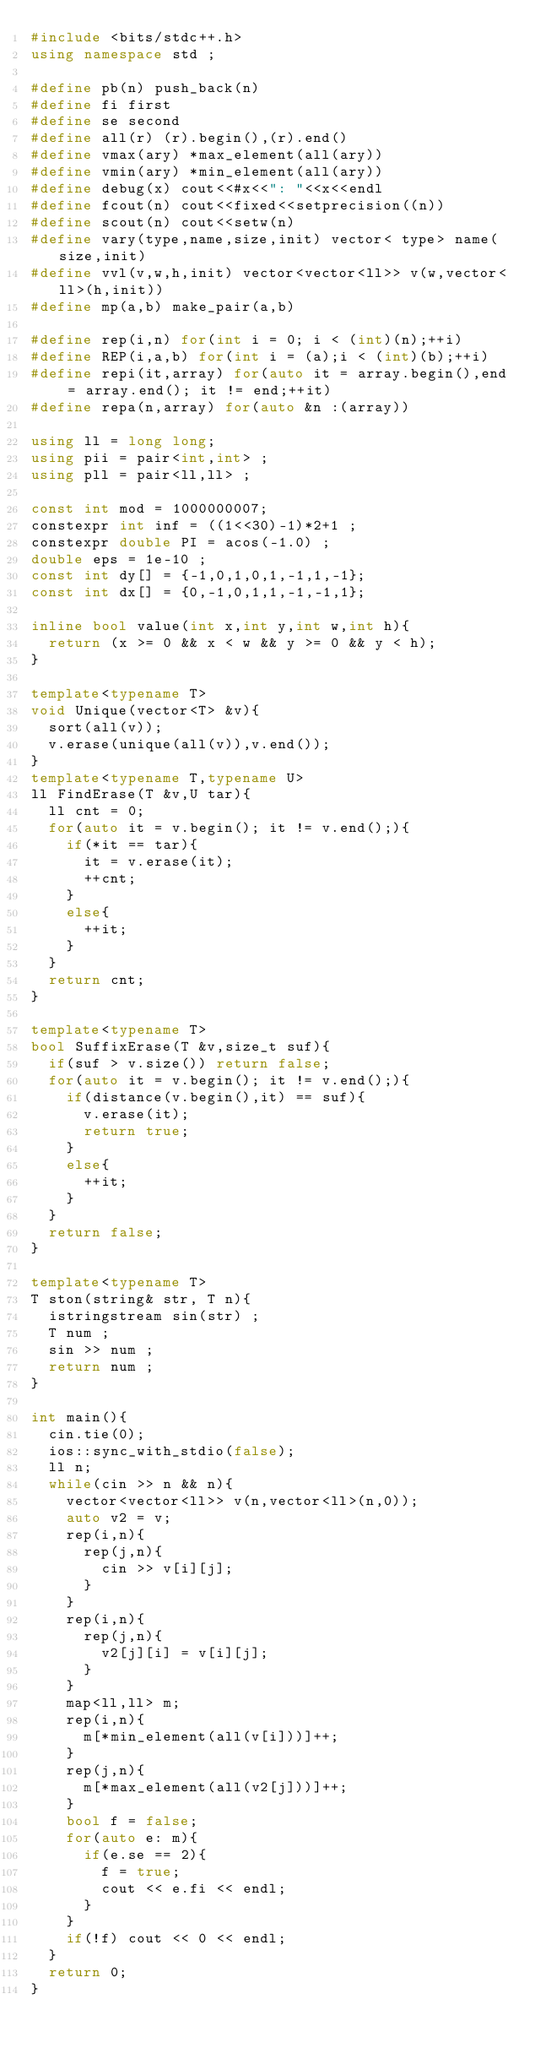Convert code to text. <code><loc_0><loc_0><loc_500><loc_500><_C++_>#include <bits/stdc++.h>
using namespace std ;

#define pb(n) push_back(n)
#define fi first
#define se second
#define all(r) (r).begin(),(r).end()
#define vmax(ary) *max_element(all(ary))
#define vmin(ary) *min_element(all(ary))
#define debug(x) cout<<#x<<": "<<x<<endl
#define fcout(n) cout<<fixed<<setprecision((n))
#define scout(n) cout<<setw(n)
#define vary(type,name,size,init) vector< type> name(size,init)
#define vvl(v,w,h,init) vector<vector<ll>> v(w,vector<ll>(h,init))
#define mp(a,b) make_pair(a,b)

#define rep(i,n) for(int i = 0; i < (int)(n);++i)
#define REP(i,a,b) for(int i = (a);i < (int)(b);++i)
#define repi(it,array) for(auto it = array.begin(),end = array.end(); it != end;++it)
#define repa(n,array) for(auto &n :(array))

using ll = long long;
using pii = pair<int,int> ;
using pll = pair<ll,ll> ;

const int mod = 1000000007;
constexpr int inf = ((1<<30)-1)*2+1 ;
constexpr double PI = acos(-1.0) ;
double eps = 1e-10 ;
const int dy[] = {-1,0,1,0,1,-1,1,-1};
const int dx[] = {0,-1,0,1,1,-1,-1,1};

inline bool value(int x,int y,int w,int h){
  return (x >= 0 && x < w && y >= 0 && y < h);
}

template<typename T>
void Unique(vector<T> &v){
  sort(all(v));
  v.erase(unique(all(v)),v.end());
}
template<typename T,typename U>
ll FindErase(T &v,U tar){
  ll cnt = 0;
  for(auto it = v.begin(); it != v.end();){
    if(*it == tar){
      it = v.erase(it);
      ++cnt;
    }
    else{
      ++it;
    }
  }
  return cnt;
}

template<typename T>
bool SuffixErase(T &v,size_t suf){
  if(suf > v.size()) return false;
  for(auto it = v.begin(); it != v.end();){
    if(distance(v.begin(),it) == suf){
      v.erase(it);
      return true;
    }
    else{
      ++it;
    }
  }
  return false;
}

template<typename T>
T ston(string& str, T n){
  istringstream sin(str) ;
  T num ;
  sin >> num ;
  return num ;
}

int main(){
  cin.tie(0);
  ios::sync_with_stdio(false);
  ll n;
  while(cin >> n && n){
    vector<vector<ll>> v(n,vector<ll>(n,0));
    auto v2 = v;
    rep(i,n){
      rep(j,n){
        cin >> v[i][j];
      }
    }
    rep(i,n){
      rep(j,n){
        v2[j][i] = v[i][j];
      }
    }
    map<ll,ll> m;
    rep(i,n){
      m[*min_element(all(v[i]))]++;
    }
    rep(j,n){
      m[*max_element(all(v2[j]))]++;
    }
    bool f = false;
    for(auto e: m){
      if(e.se == 2){
        f = true;
        cout << e.fi << endl;
      }
    }
    if(!f) cout << 0 << endl;
  }
  return 0;
}</code> 